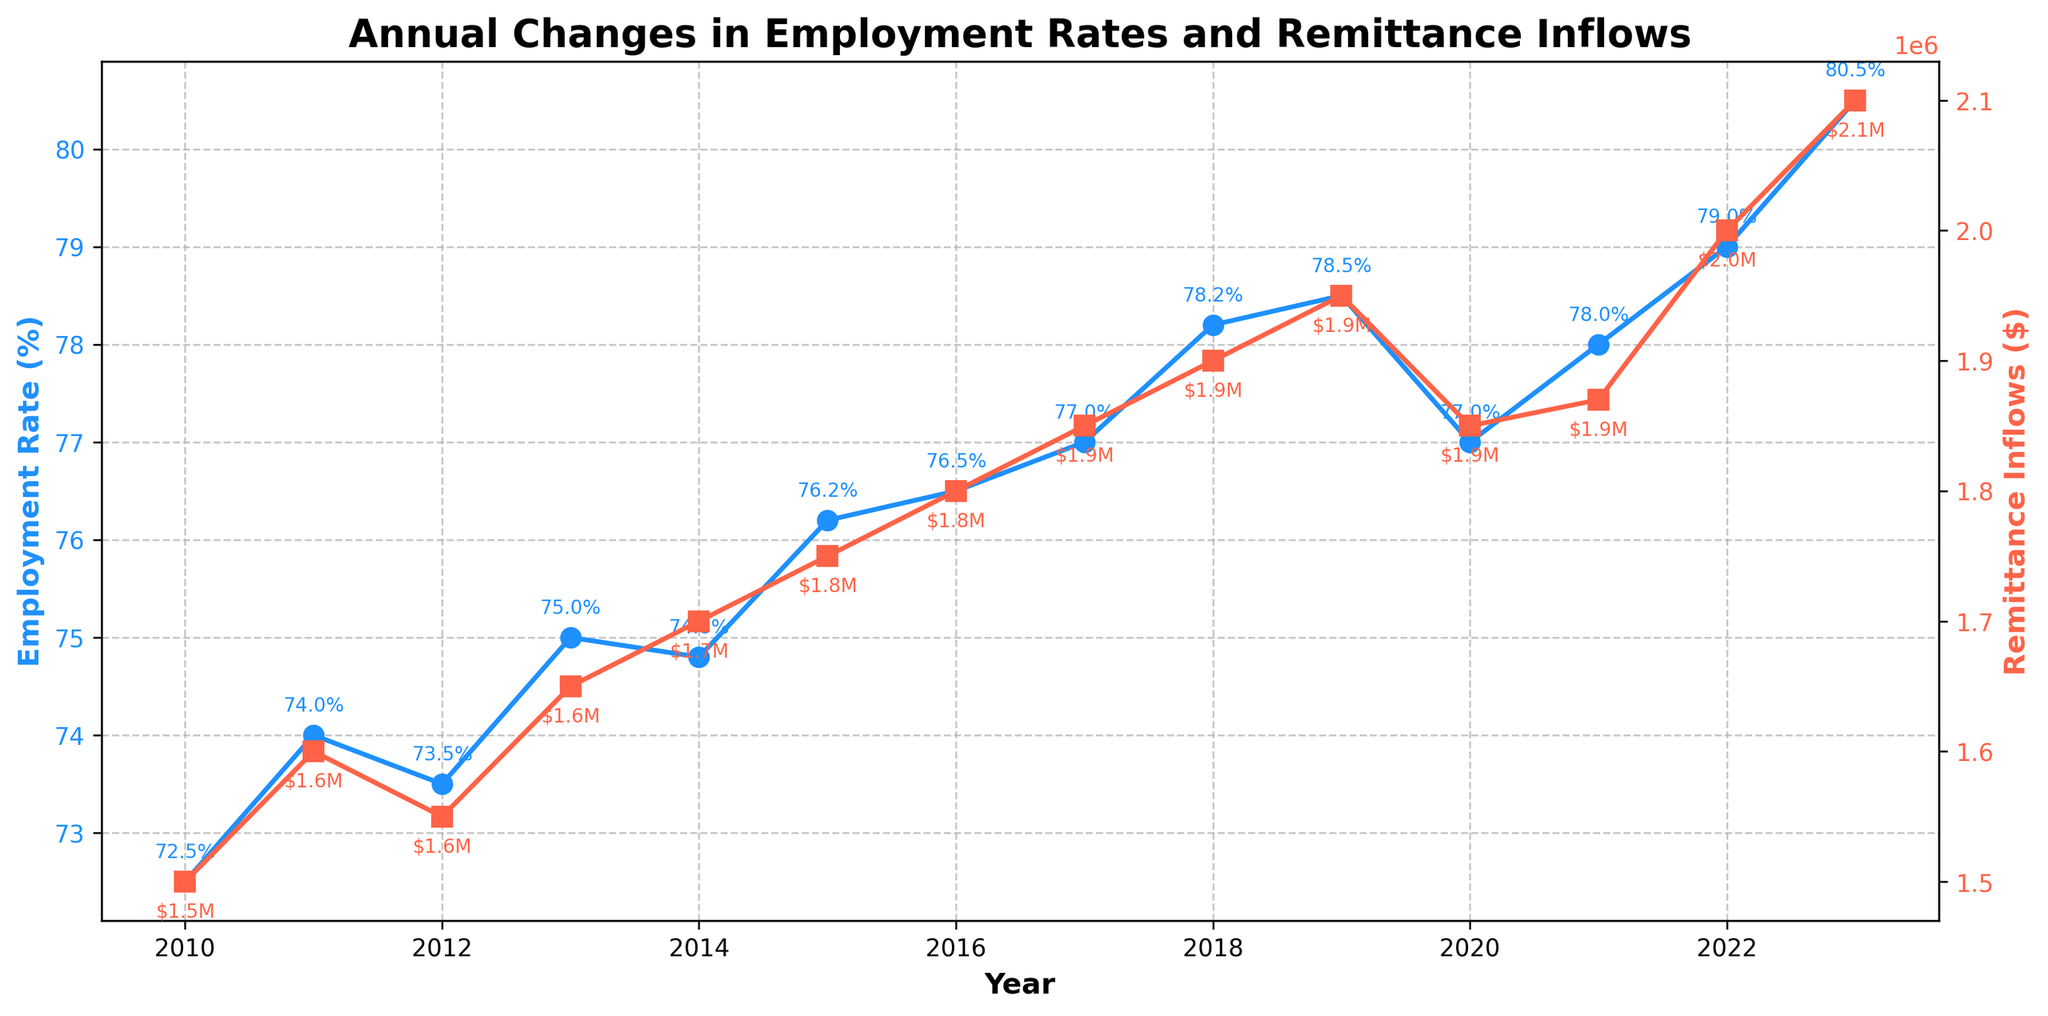What is the title of the figure? The title of the figure is displayed at the top and indicates the main subject of the plot.
Answer: Annual Changes in Employment Rates and Remittance Inflows How many years are covered in the figure? The x-axis shows the years from the start to the end, and we count the number of unique years. The years range from 2010 to 2023.
Answer: 14 What was the Employment Rate in 2019? Identify the data point for 2019 on the employment rate line (blue line) and note its value.
Answer: 78.5% What's the trend in Remittance Inflows from 2010 to 2023? Observe the red line representing remittance inflows over the years and describe its direction. The red line shows a generally increasing trend.
Answer: Increasing Which year saw the highest Employment Rate, and what was it? Look for the highest point on the blue line and identify the corresponding year. The highest employment rate was in 2023.
Answer: 2023, 80.5% How did the Employment Rate change from 2012 to 2013? Compare the Employment Rate value in 2012 with the one in 2013 by looking at the blue line. The Employment Rate increased from 73.5% to 75.0%.
Answer: Increased by 1.5% Compute the average Employment Rate for the years 2015-2017. Sum the Employment Rates for the years 2015, 2016, and 2017 and then divide by 3 to find the average. (76.2 + 76.5 + 77.0) / 3 = 76.57%
Answer: 76.57% Is there a correlation between the Employment Rate and Remittance Inflows? Observe the overall trends of both the blue and red lines. If both lines generally move in the same direction, there is a positive correlation. Both lines are generally increasing, indicating a positive correlation.
Answer: Yes, a positive correlation How did Remittance Inflows change from 2020 to 2021? Compare the Remittance Inflows value in 2020 with the one in 2021 by looking at the red line. The Remittance Inflows increased from $1850000 to $1870000.
Answer: Increased by $200000 What was the difference in Remittance Inflows between 2016 and 2018? Calculate the difference by subtracting the 2016 value from the 2018 value. 1900000 - 1800000 = 100000
Answer: $100000 What was the employment rate when Remittance Inflows were $1700000? Find the data point where Remittance Inflows were $1700000 and check the corresponding Employment Rate. This happened in 2014 when the employment rate was 74.8%.
Answer: 74.8% 